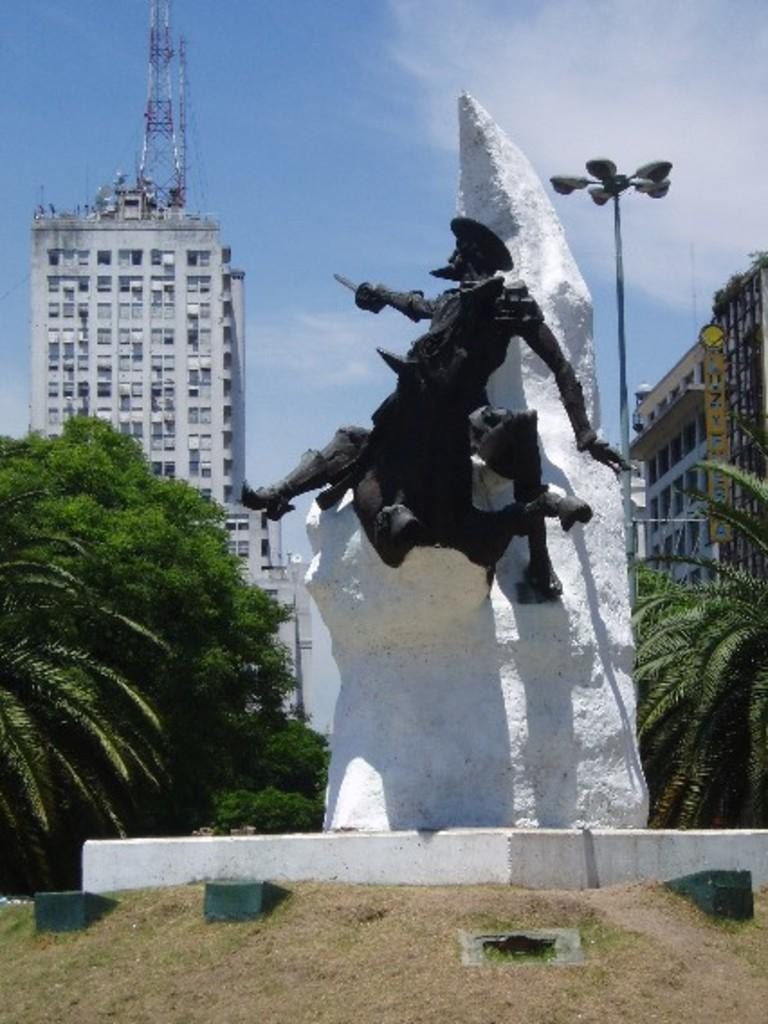What is the main subject in the middle of the image? There is a statue in the middle of the image. What can be seen in the background of the image? There are trees, buildings, poles, and a tower in the background of the image. Can you see any ghosts interacting with the statue in the image? There are no ghosts present in the image; it only features a statue, trees, buildings, poles, and a tower. What type of control is being exerted over the statue in the image? There is no control being exerted over the statue in the image; it is a stationary object. 